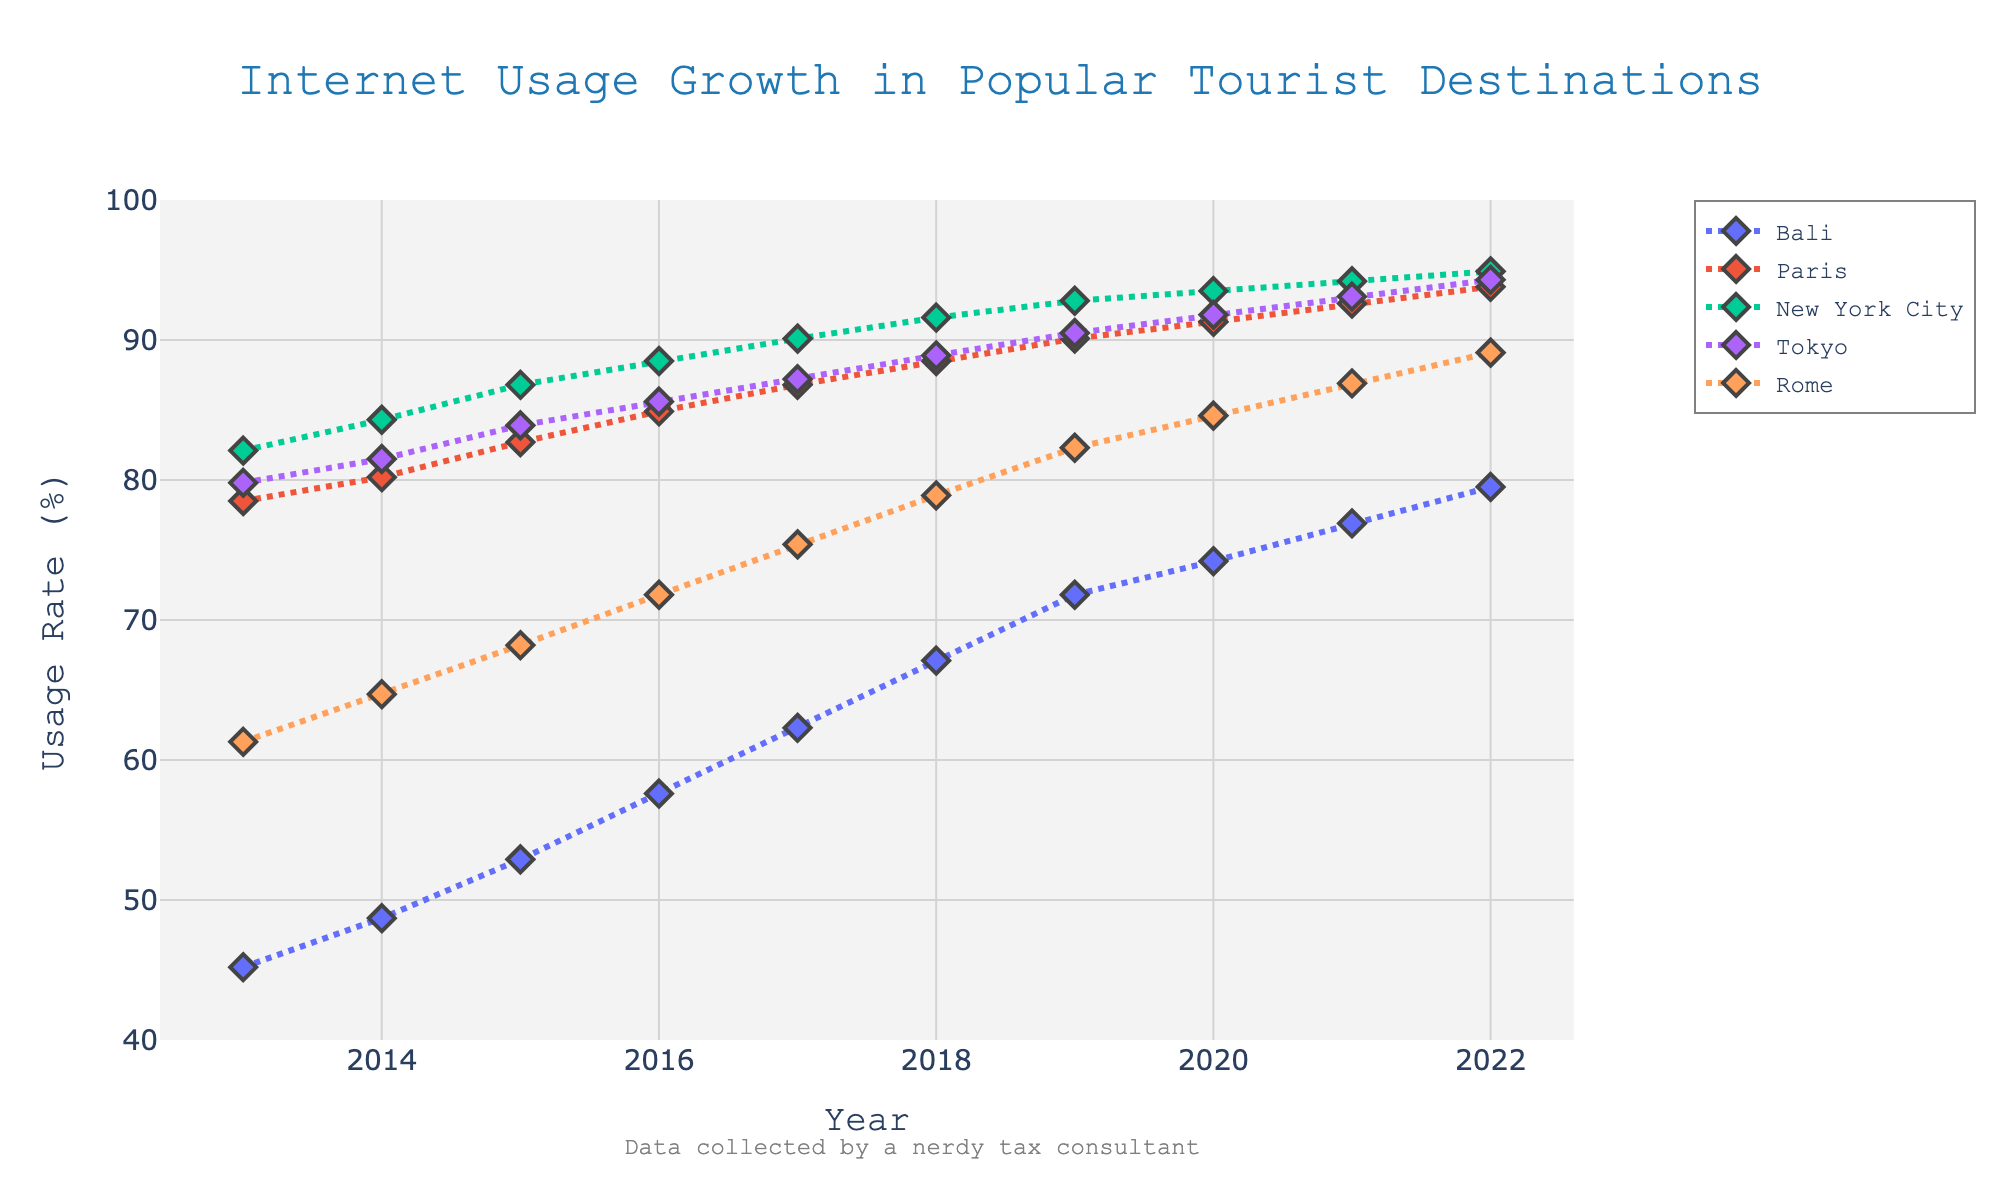What was the usage rate in Bali in 2020? Look at the point on the Bali line in 2020, which is around 74.2%
Answer: 74.2% Which city had the highest internet usage rate in 2013? Compare the data points for all cities in 2013: Bali (45.2), Paris (78.5), New York City (82.1), Tokyo (79.8), Rome (61.3). New York City has the highest rate.
Answer: New York City By how much did the internet usage rate in Tokyo increase from 2013 to 2022? Subtract the 2013 value for Tokyo from the 2022 value: 94.3 - 79.8
Answer: 14.5 In what year did Rome's internet usage rate first exceed 80%? Track the data points for Rome and find the first year the usage exceeds 80, which is 2019 (82.3)
Answer: 2019 Between which two consecutive years did Bali see the highest increase in internet usage? Calculate the annual differences for Bali, then find the largest: 2013-2014 (3.5), 2014-2015 (4.2), 2015-2016 (4.7), 2016-2017 (4.7), 2017-2018 (4.8), 2018-2019 (4.7), 2019-2020 (2.4), 2020-2021 (2.7), 2021-2022 (2.6). The highest increase is from 2017 to 2018.
Answer: 2017-2018 In 2022, how do Paris, Tokyo, and Rome's internet usage rates compare? Observe the 2022 values for Paris (93.8), Tokyo (94.3), and Rome (89.1). Tokyo > Paris > Rome.
Answer: Tokyo > Paris > Rome What is the average internet usage rate in New York City over the decade? Sum of the New York City values divided by 10: (82.1+84.3+86.8+88.5+90.1+91.6+92.8+93.5+94.2+94.9)/10 = 898.8/10 = 89.88
Answer: 89.9 Did Paris ever have a higher usage rate than Tokyo? Compare the respective yearly values. In every year, Paris's rate is lower than Tokyo's rate.
Answer: No 